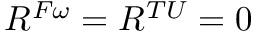<formula> <loc_0><loc_0><loc_500><loc_500>R ^ { F \omega } = R ^ { T U } = 0</formula> 